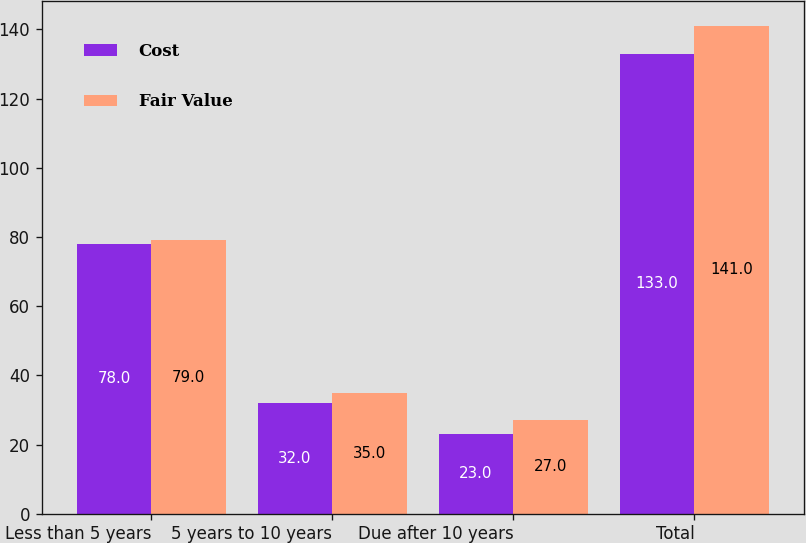Convert chart. <chart><loc_0><loc_0><loc_500><loc_500><stacked_bar_chart><ecel><fcel>Less than 5 years<fcel>5 years to 10 years<fcel>Due after 10 years<fcel>Total<nl><fcel>Cost<fcel>78<fcel>32<fcel>23<fcel>133<nl><fcel>Fair Value<fcel>79<fcel>35<fcel>27<fcel>141<nl></chart> 